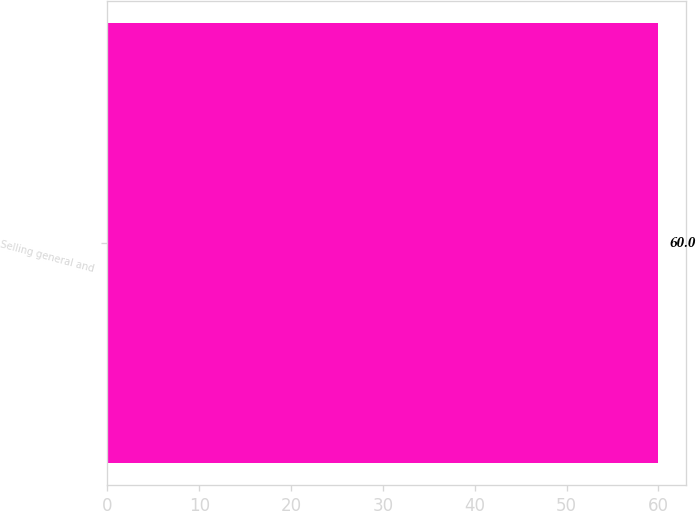Convert chart. <chart><loc_0><loc_0><loc_500><loc_500><bar_chart><fcel>Selling general and<nl><fcel>60<nl></chart> 